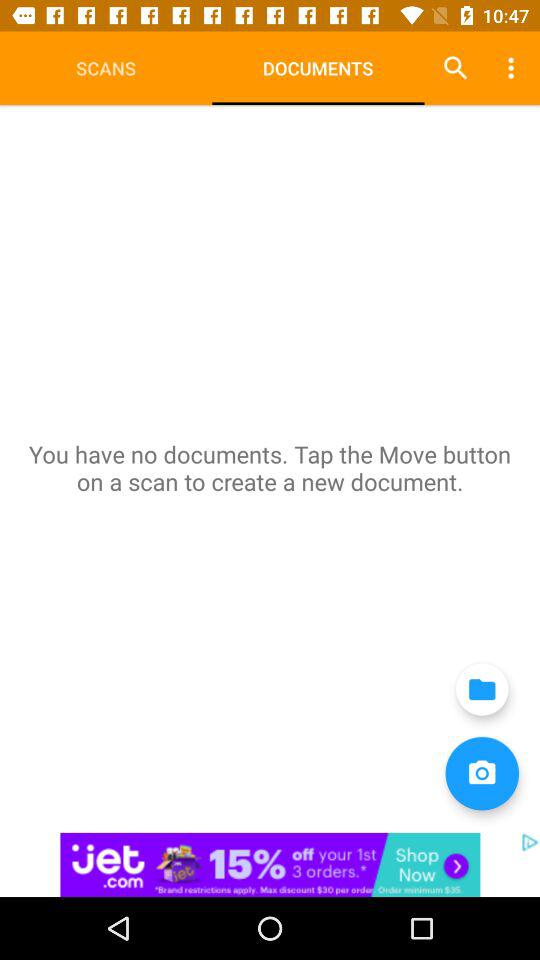Which tab is selected? The selected tab is "DOCUMENTS". 